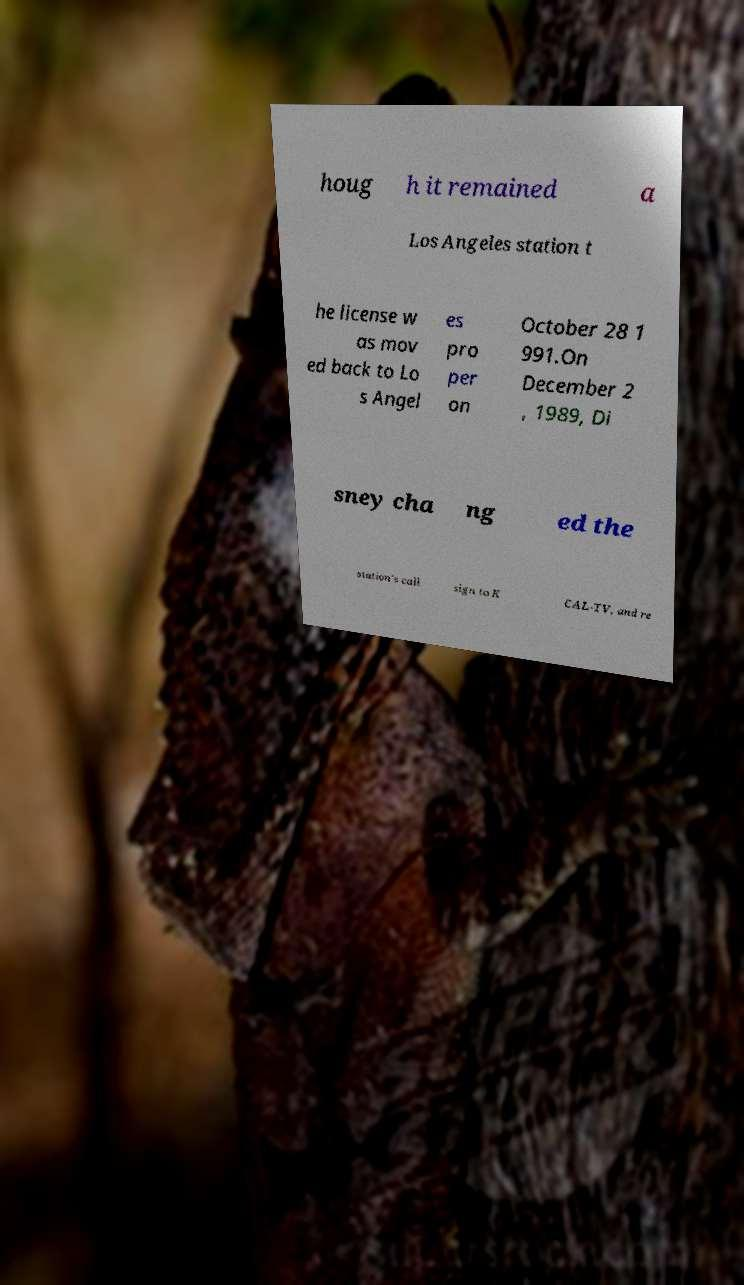Can you read and provide the text displayed in the image?This photo seems to have some interesting text. Can you extract and type it out for me? houg h it remained a Los Angeles station t he license w as mov ed back to Lo s Angel es pro per on October 28 1 991.On December 2 , 1989, Di sney cha ng ed the station's call sign to K CAL-TV, and re 